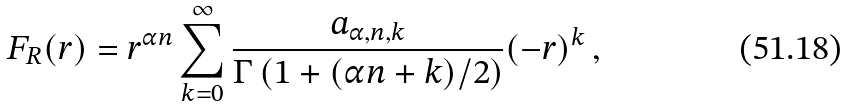Convert formula to latex. <formula><loc_0><loc_0><loc_500><loc_500>F _ { R } ( r ) = r ^ { \alpha n } \sum _ { k = 0 } ^ { \infty } \frac { a _ { \alpha , n , k } } { \Gamma \left ( 1 + ( \alpha n + k ) / 2 \right ) } ( - r ) ^ { k } \, ,</formula> 